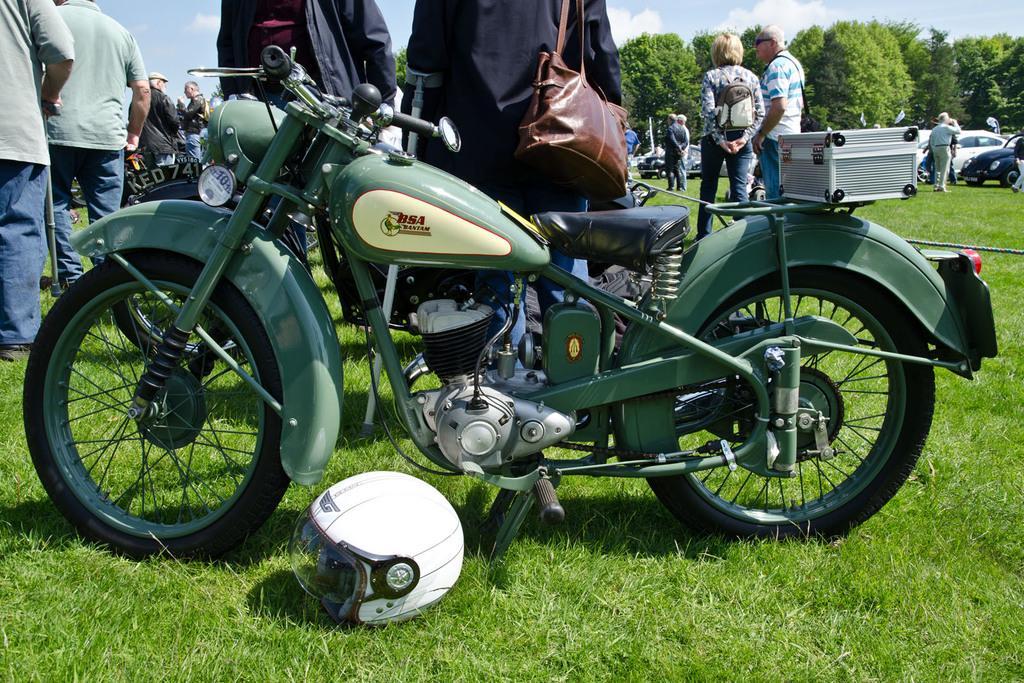Please provide a concise description of this image. Group of people standing and these two persons are wear bag. A far we can see trees, sky with clouds. We can see vehicles and helmet on the grass. 